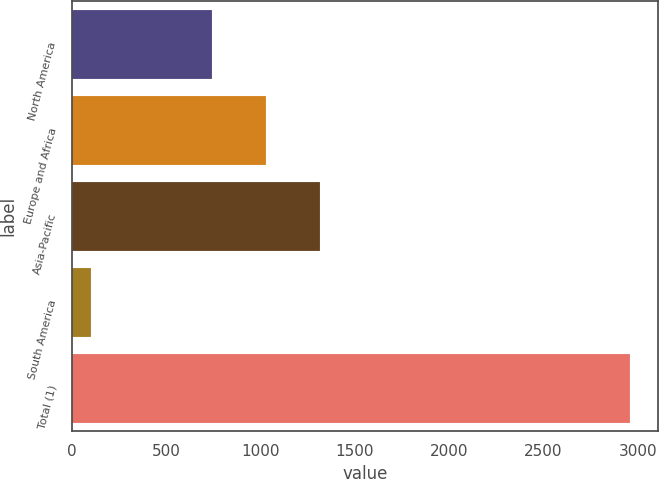Convert chart. <chart><loc_0><loc_0><loc_500><loc_500><bar_chart><fcel>North America<fcel>Europe and Africa<fcel>Asia-Pacific<fcel>South America<fcel>Total (1)<nl><fcel>743<fcel>1028.8<fcel>1314.6<fcel>103<fcel>2961<nl></chart> 